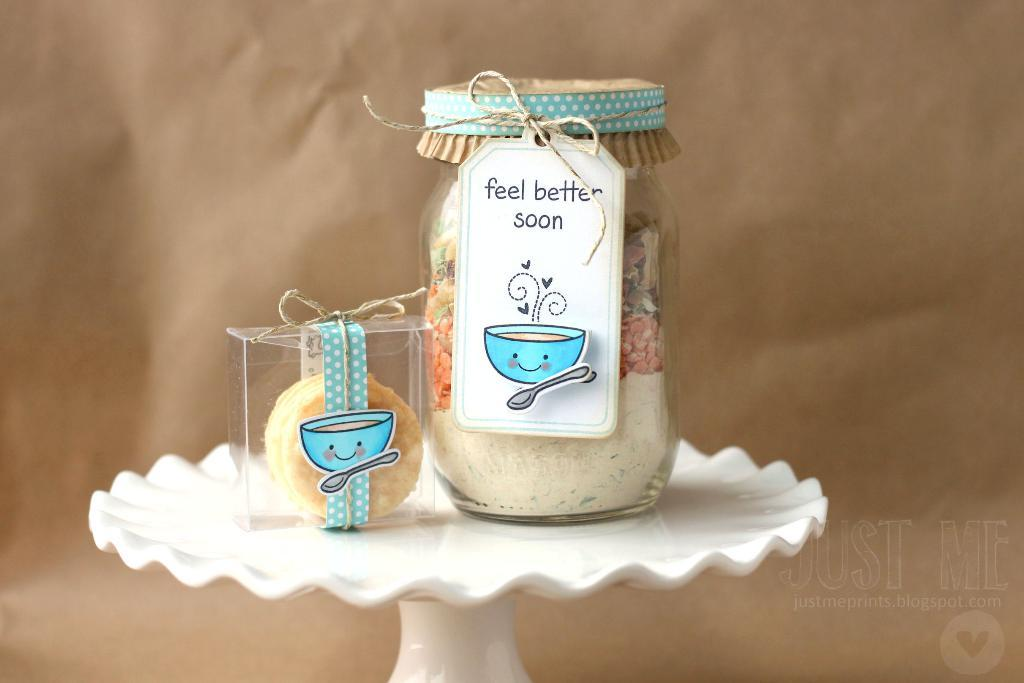<image>
Create a compact narrative representing the image presented. The tag on the jar indicates it's a gift for someone who is sick and conveys the gift giver hopes they feel better soon. 